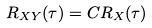Convert formula to latex. <formula><loc_0><loc_0><loc_500><loc_500>R _ { X Y } ( \tau ) = C R _ { X } ( \tau )</formula> 